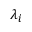Convert formula to latex. <formula><loc_0><loc_0><loc_500><loc_500>\lambda _ { i }</formula> 